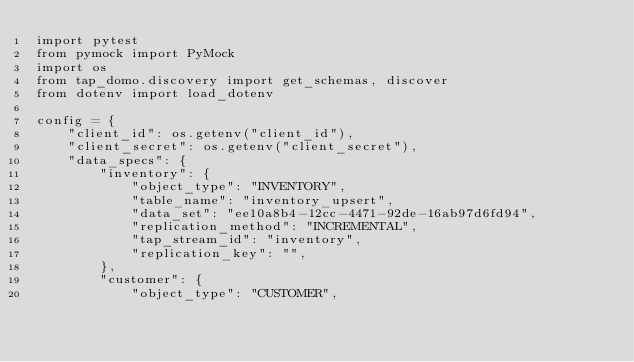Convert code to text. <code><loc_0><loc_0><loc_500><loc_500><_Python_>import pytest
from pymock import PyMock
import os
from tap_domo.discovery import get_schemas, discover
from dotenv import load_dotenv

config = {
    "client_id": os.getenv("client_id"),
    "client_secret": os.getenv("client_secret"),
    "data_specs": {
        "inventory": {
            "object_type": "INVENTORY",
            "table_name": "inventory_upsert",
            "data_set": "ee10a8b4-12cc-4471-92de-16ab97d6fd94",
            "replication_method": "INCREMENTAL",
            "tap_stream_id": "inventory",
            "replication_key": "",
        },
        "customer": {
            "object_type": "CUSTOMER",</code> 